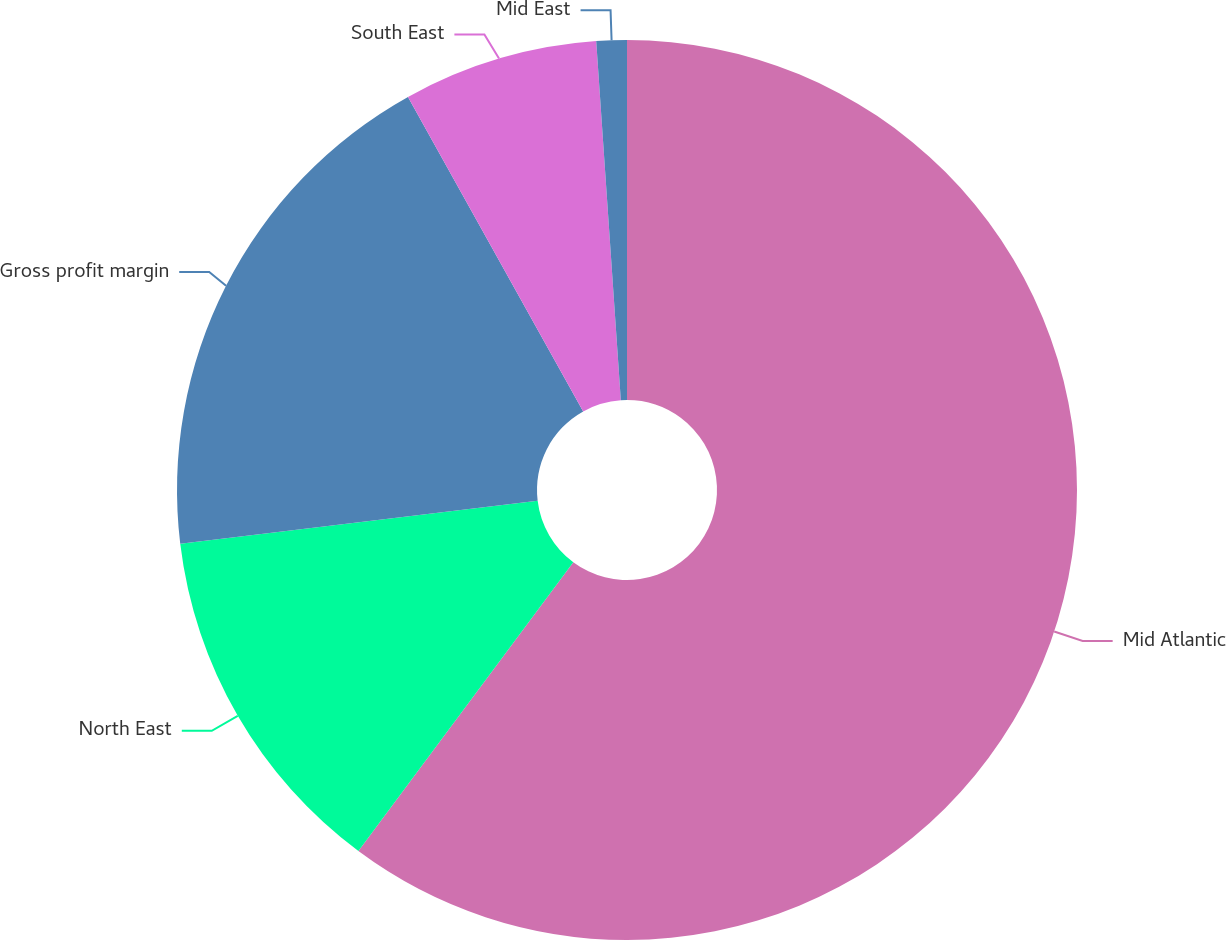Convert chart to OTSL. <chart><loc_0><loc_0><loc_500><loc_500><pie_chart><fcel>Mid Atlantic<fcel>North East<fcel>Gross profit margin<fcel>South East<fcel>Mid East<nl><fcel>60.18%<fcel>12.91%<fcel>18.82%<fcel>7.0%<fcel>1.09%<nl></chart> 